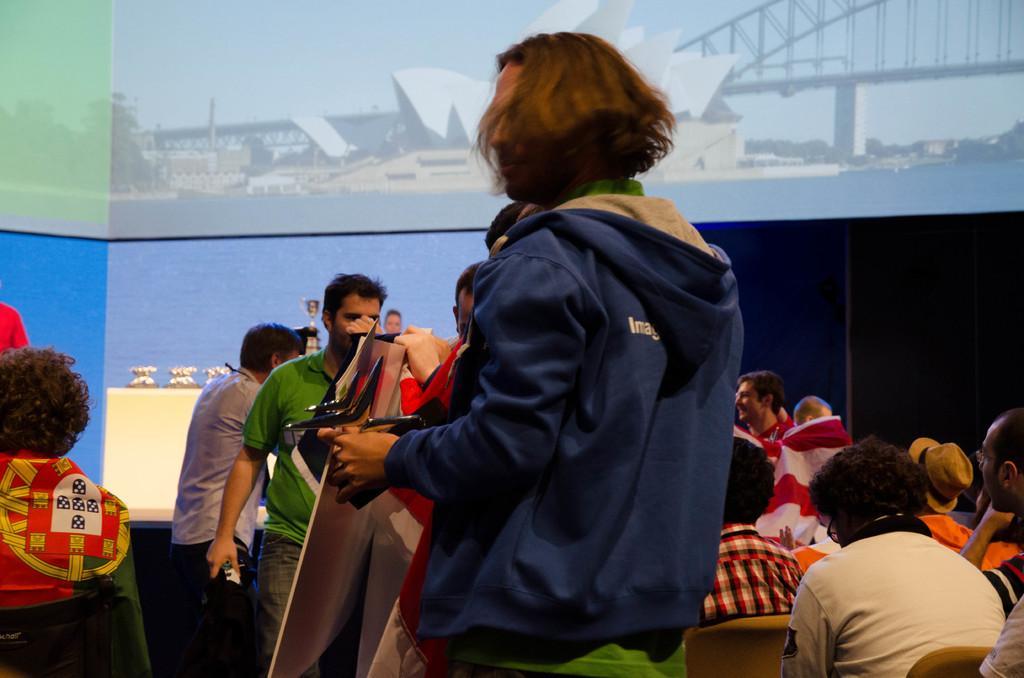How would you summarize this image in a sentence or two? In front of the image there is a person standing. Behind the person there is a person standing and holding a board in the hand. In the image there are few people standing and some other people are sitting. In front of them there is a stage with table. On the table there are trophies. And in the background there is a screen with images on it. 